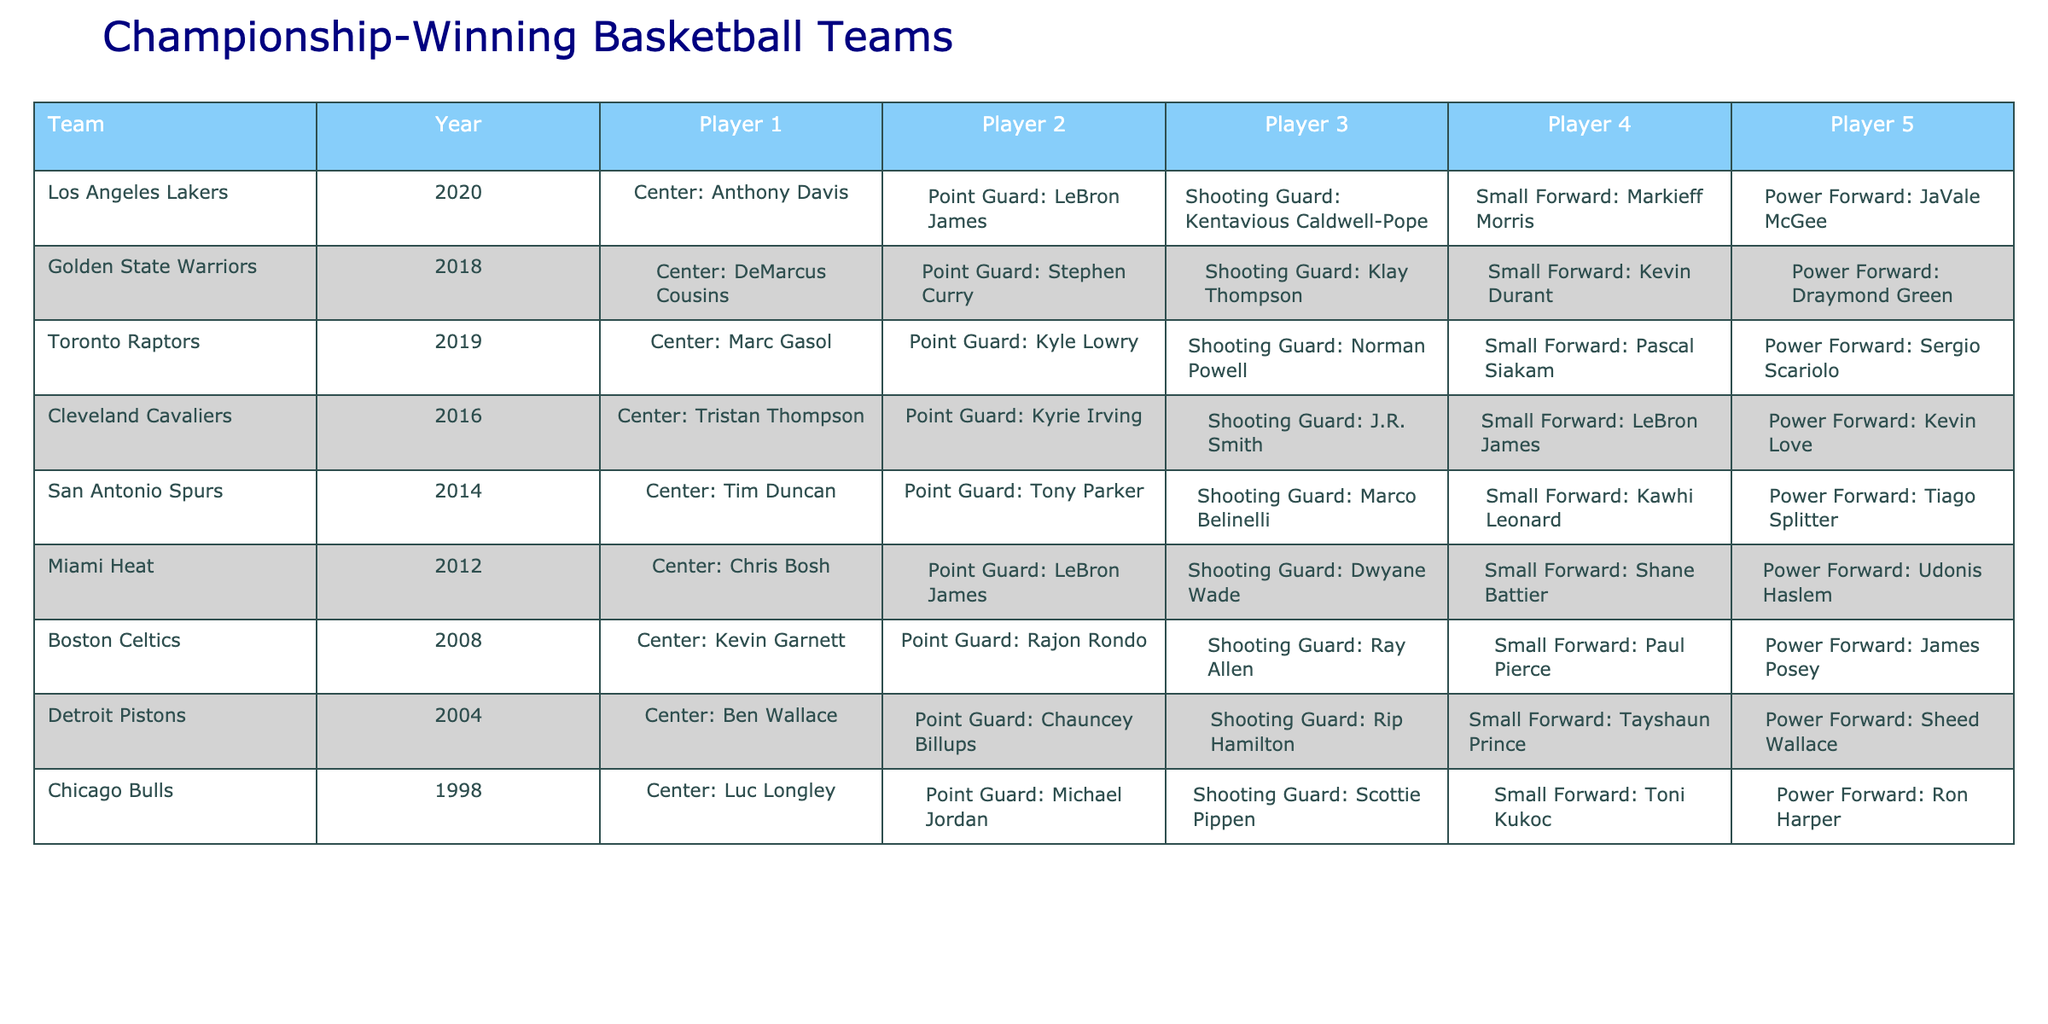What positions are played by the Los Angeles Lakers' championship-winning team in 2020? Referring to the table, the Los Angeles Lakers in 2020 have the following player positions: Center (Anthony Davis), Point Guard (LeBron James), Shooting Guard (Kentavious Caldwell-Pope), Small Forward (Markieff Morris), and Power Forward (JaVale McGee).
Answer: Center, Point Guard, Shooting Guard, Small Forward, Power Forward Which team had a Center player named Chris Bosh? By scanning the table, it shows that the Miami Heat had a Center player named Chris Bosh in 2012.
Answer: Miami Heat How many players' positions are listed for the Golden State Warriors? The table lists the positions for all five players of the Golden State Warriors for 2018, which includes Center, Point Guard, Shooting Guard, Small Forward, and Power Forward.
Answer: 5 What is the most recent championship year represented in the table? Looking at the table, the most recent championship year is 2020, which belongs to the Los Angeles Lakers.
Answer: 2020 Did the Toronto Raptors win their championship with a Power Forward named Pascal Siakam? The table shows that the Toronto Raptors won in 2019 with Pascal Siakam listed as the Power Forward, making the statement true.
Answer: Yes Which team has the combination of players featuring both LeBron James and Kevin Love? The table indicates that LeBron James and Kevin Love are part of the Cleveland Cavaliers' team composition in 2016, therefore, they share the same team.
Answer: Cleveland Cavaliers In which championship year did the San Antonio Spurs win with a Point Guard named Tony Parker? Referring to the table, the San Antonio Spurs won their championship in 2014 with Tony Parker as the Point Guard.
Answer: 2014 What fraction of the championship-winning teams included a player in the Shooting Guard position? Scanning through the table, six out of eight teams featured a player in the Shooting Guard position. Thus, the fraction is 6/8 or simplified, 3/4.
Answer: 3/4 Were there any championship-winning teams with a player listed as Small Forward named Dwyane Wade? The table does not list Dwyane Wade as a Small Forward; he is indicated as a Shooting Guard for the Miami Heat in 2012, so this statement is false.
Answer: No Which player positions are most common among the championship teams? Upon reviewing the data, all championship-winning teams have a player in the Center position, while each team has varying players in the other positions but mainly features one Point Guard and one Shooting Guard.
Answer: Center, Point Guard, Shooting Guard 